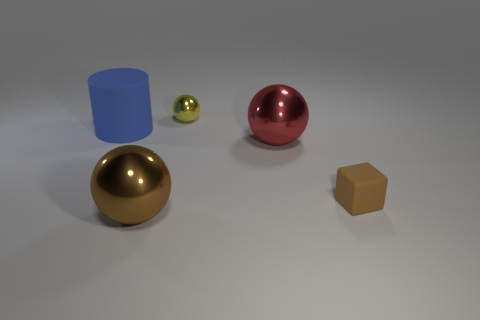Does the lighting suggest a specific time of day or setting? The lighting in the image is soft and diffused, with no harsh shadows, which isn't particularly indicative of any specific time of day. It appears to be studio lighting commonly used in product photography or illustration renderings to highlight the form and material qualities of the objects without any strong directional light that could suggest a natural setting. 